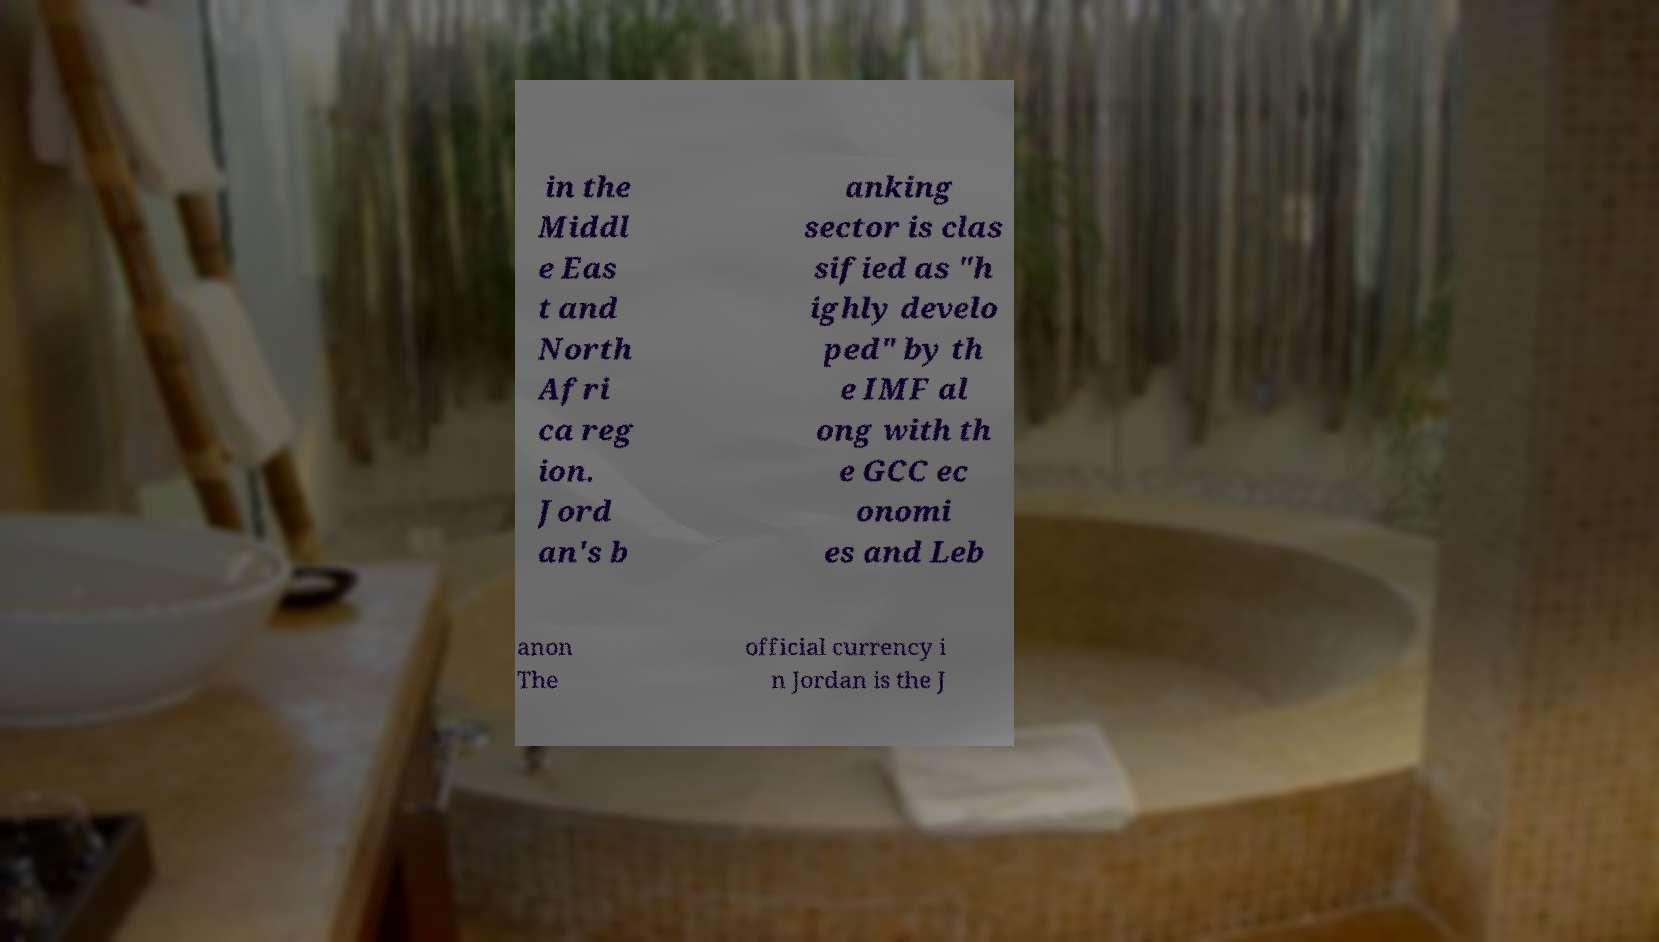Could you extract and type out the text from this image? in the Middl e Eas t and North Afri ca reg ion. Jord an's b anking sector is clas sified as "h ighly develo ped" by th e IMF al ong with th e GCC ec onomi es and Leb anon The official currency i n Jordan is the J 